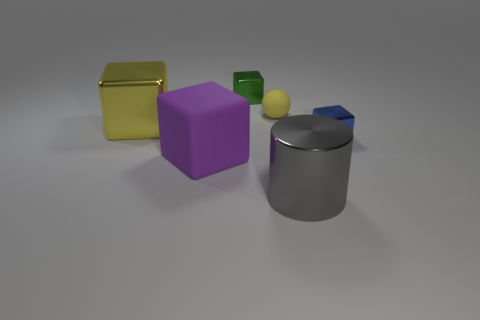Subtract all small blue cubes. How many cubes are left? 3 Add 2 big things. How many objects exist? 8 Subtract all blue blocks. How many blocks are left? 3 Subtract all spheres. How many objects are left? 5 Subtract all green cubes. Subtract all blue cylinders. How many cubes are left? 3 Subtract all tiny things. Subtract all green blocks. How many objects are left? 2 Add 5 big cylinders. How many big cylinders are left? 6 Add 2 red matte cylinders. How many red matte cylinders exist? 2 Subtract 1 purple blocks. How many objects are left? 5 